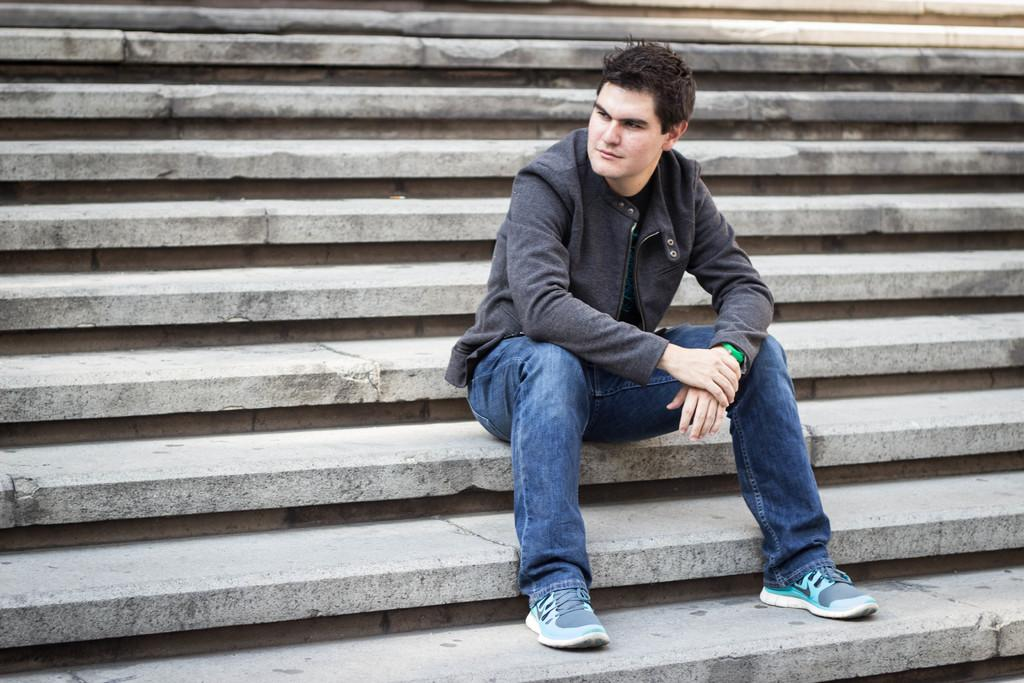Who is the main subject in the image? There is a man in the image. What is the man doing in the image? The man is sitting on the stairs. In which direction is the man looking? The man is looking to the left side. What type of board is the man holding in the image? There is no board present in the image. 